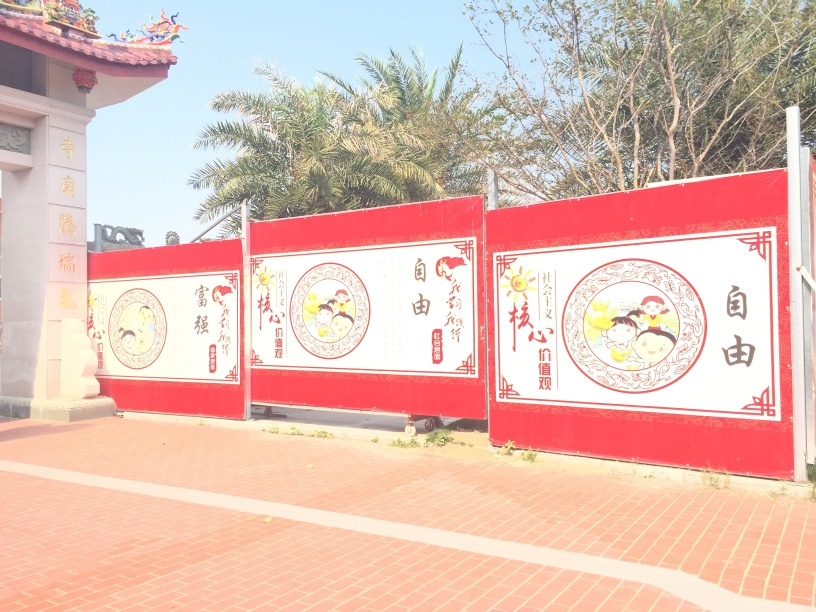Describe the overall atmosphere of the place shown in the image. The vibrant red color of the panels, commonly associated with good fortune and joy in Chinese culture, combined with the clear blue skies, creates an atmosphere that is festive and bright. The intricate illustrations and calligraphy give a sense of cultural pride and importance to the depicted narratives or symbols. It's peaceful, with no visible people, suggesting a tranquil moment captured in the day. 